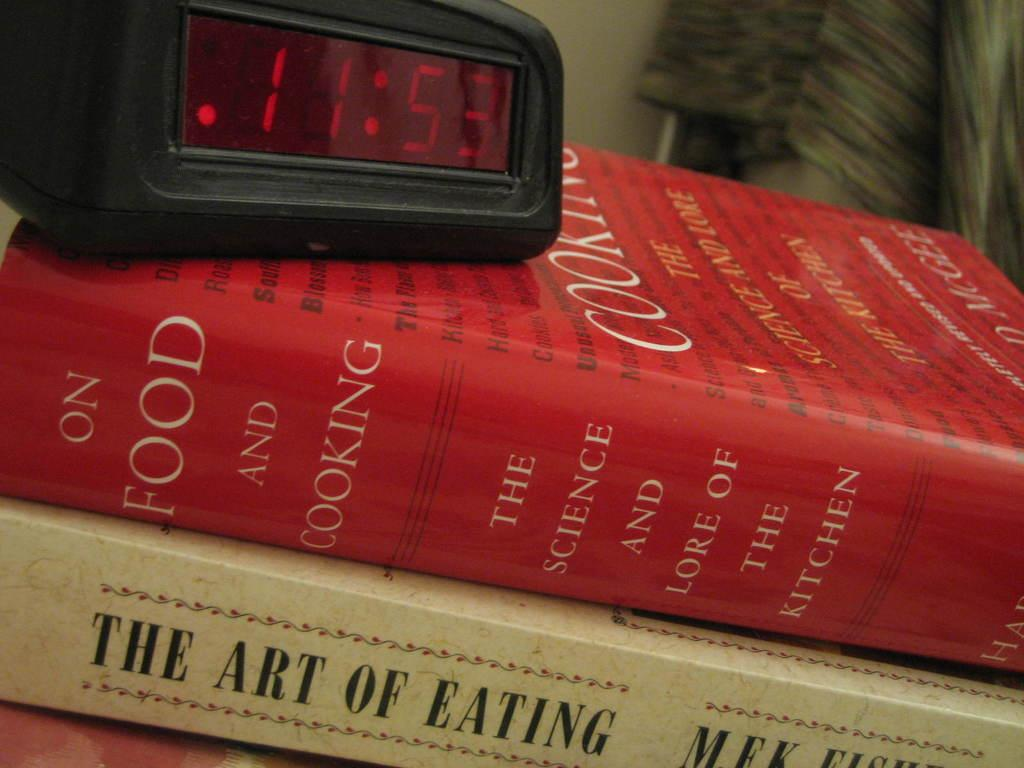<image>
Present a compact description of the photo's key features. A book titled " The Art of Eating" and " The science and lore of the kitchen". 